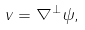Convert formula to latex. <formula><loc_0><loc_0><loc_500><loc_500>v = \nabla ^ { \perp } \psi ,</formula> 